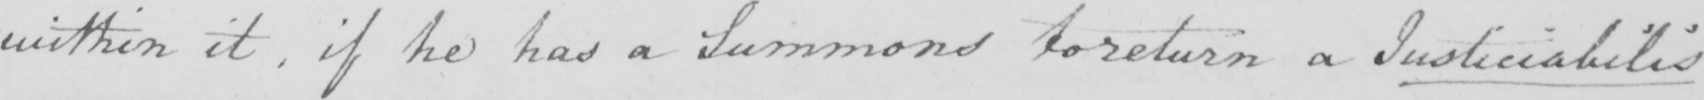Please provide the text content of this handwritten line. within it , if he has a Summons to return a Justiciabilis 